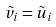Convert formula to latex. <formula><loc_0><loc_0><loc_500><loc_500>\tilde { v } _ { i } = \tilde { u } _ { i }</formula> 